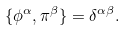Convert formula to latex. <formula><loc_0><loc_0><loc_500><loc_500>\{ \phi ^ { \alpha } , \pi ^ { \beta } \} = \delta ^ { \alpha \beta } .</formula> 